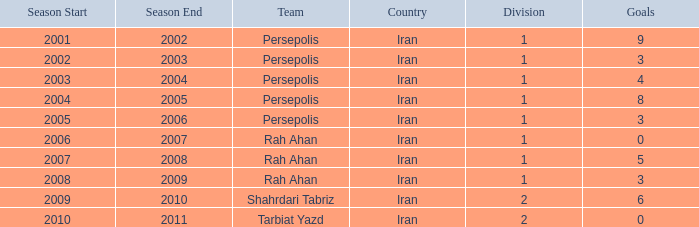Could you help me parse every detail presented in this table? {'header': ['Season Start', 'Season End', 'Team', 'Country', 'Division', 'Goals'], 'rows': [['2001', '2002', 'Persepolis', 'Iran', '1', '9'], ['2002', '2003', 'Persepolis', 'Iran', '1', '3'], ['2003', '2004', 'Persepolis', 'Iran', '1', '4'], ['2004', '2005', 'Persepolis', 'Iran', '1', '8'], ['2005', '2006', 'Persepolis', 'Iran', '1', '3'], ['2006', '2007', 'Rah Ahan', 'Iran', '1', '0'], ['2007', '2008', 'Rah Ahan', 'Iran', '1', '5'], ['2008', '2009', 'Rah Ahan', 'Iran', '1', '3'], ['2009', '2010', 'Shahrdari Tabriz', 'Iran', '2', '6'], ['2010', '2011', 'Tarbiat Yazd', 'Iran', '2', '0']]} What is the lowest Division, when Goals is less than 5, and when Season is "2002-03"? 1.0. 